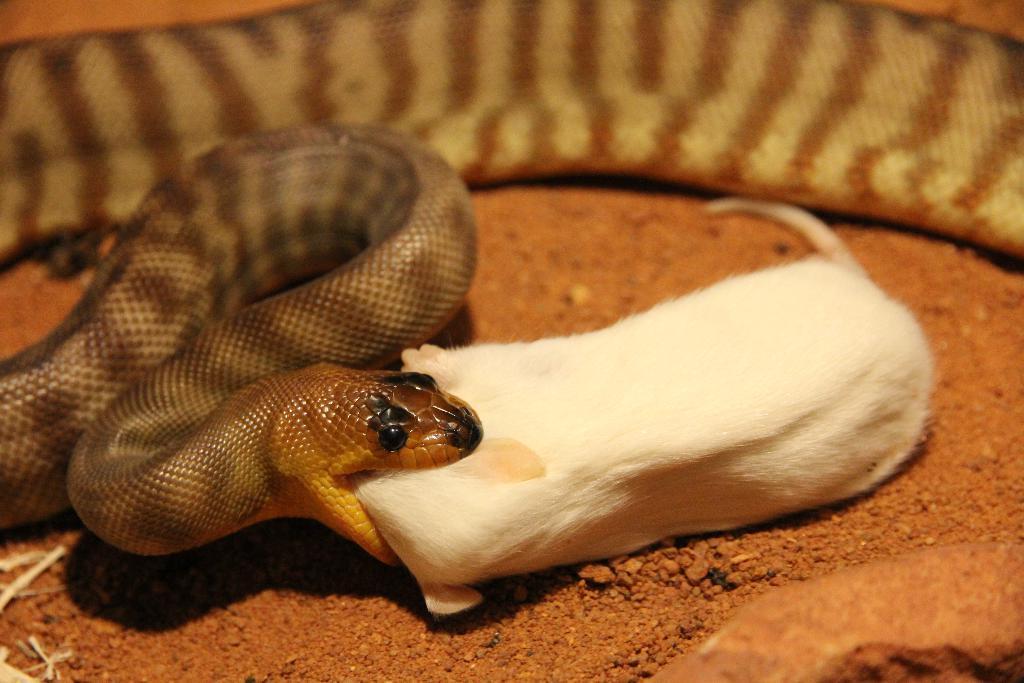In one or two sentences, can you explain what this image depicts? In this image I can see a snake which is brown, gold and black in color and I can see it is biting a rat which is white in color and I can see the ground. 